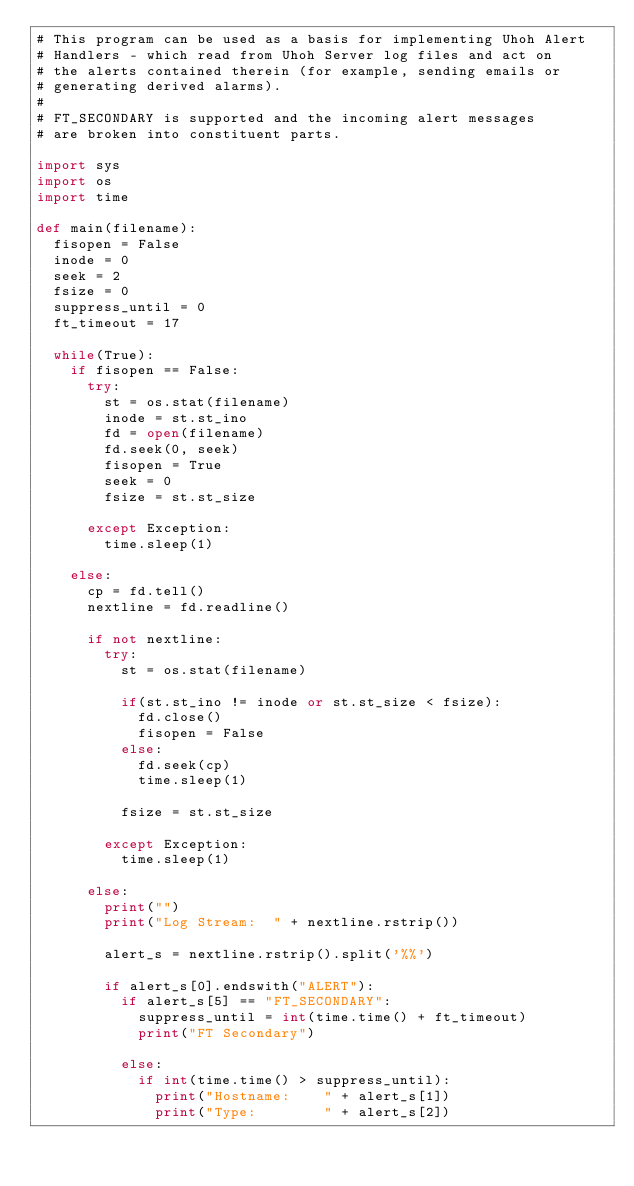Convert code to text. <code><loc_0><loc_0><loc_500><loc_500><_Python_># This program can be used as a basis for implementing Uhoh Alert
# Handlers - which read from Uhoh Server log files and act on
# the alerts contained therein (for example, sending emails or
# generating derived alarms).
#
# FT_SECONDARY is supported and the incoming alert messages
# are broken into constituent parts.

import sys
import os
import time

def main(filename):
  fisopen = False
  inode = 0
  seek = 2
  fsize = 0
  suppress_until = 0
  ft_timeout = 17

  while(True):
    if fisopen == False:
      try:
        st = os.stat(filename)
        inode = st.st_ino
        fd = open(filename)
        fd.seek(0, seek)
        fisopen = True
        seek = 0
        fsize = st.st_size

      except Exception:
        time.sleep(1)

    else:
      cp = fd.tell()
      nextline = fd.readline()

      if not nextline:
        try:
          st = os.stat(filename)

          if(st.st_ino != inode or st.st_size < fsize):
            fd.close()
            fisopen = False
          else:
            fd.seek(cp)
            time.sleep(1)

          fsize = st.st_size

        except Exception:
          time.sleep(1)

      else:
        print("")
        print("Log Stream:  " + nextline.rstrip())

        alert_s = nextline.rstrip().split('%%')

        if alert_s[0].endswith("ALERT"):
          if alert_s[5] == "FT_SECONDARY":
            suppress_until = int(time.time() + ft_timeout)
            print("FT Secondary")

          else:
            if int(time.time() > suppress_until):
              print("Hostname:    " + alert_s[1])
              print("Type:        " + alert_s[2])</code> 